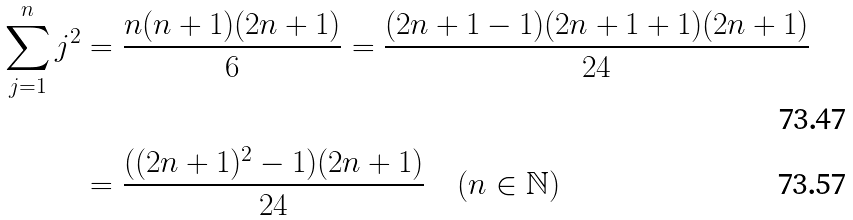<formula> <loc_0><loc_0><loc_500><loc_500>\sum _ { j = 1 } ^ { n } j ^ { 2 } & = \frac { n ( n + 1 ) ( 2 n + 1 ) } 6 = \frac { ( 2 n + 1 - 1 ) ( 2 n + 1 + 1 ) ( 2 n + 1 ) } { 2 4 } \\ & = \frac { ( ( 2 n + 1 ) ^ { 2 } - 1 ) ( 2 n + 1 ) } { 2 4 } \quad ( n \in \mathbb { N } )</formula> 